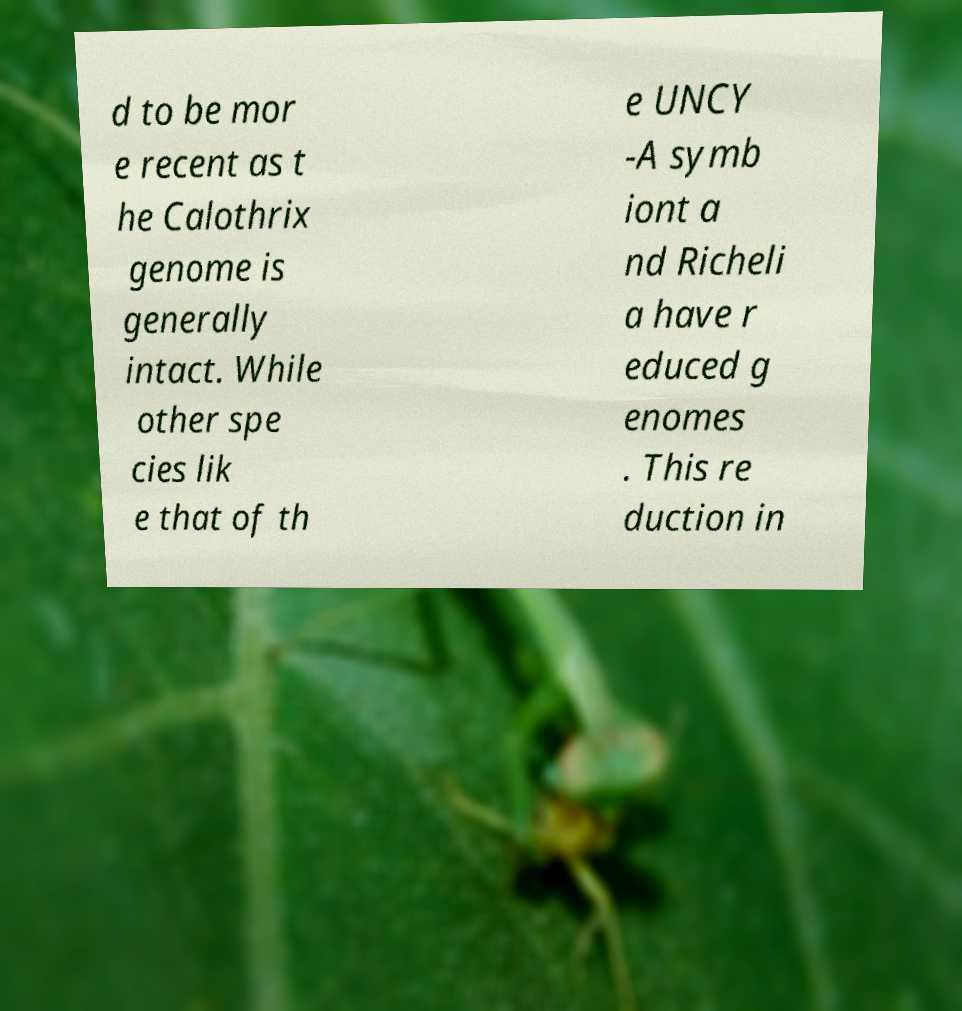What messages or text are displayed in this image? I need them in a readable, typed format. d to be mor e recent as t he Calothrix genome is generally intact. While other spe cies lik e that of th e UNCY -A symb iont a nd Richeli a have r educed g enomes . This re duction in 